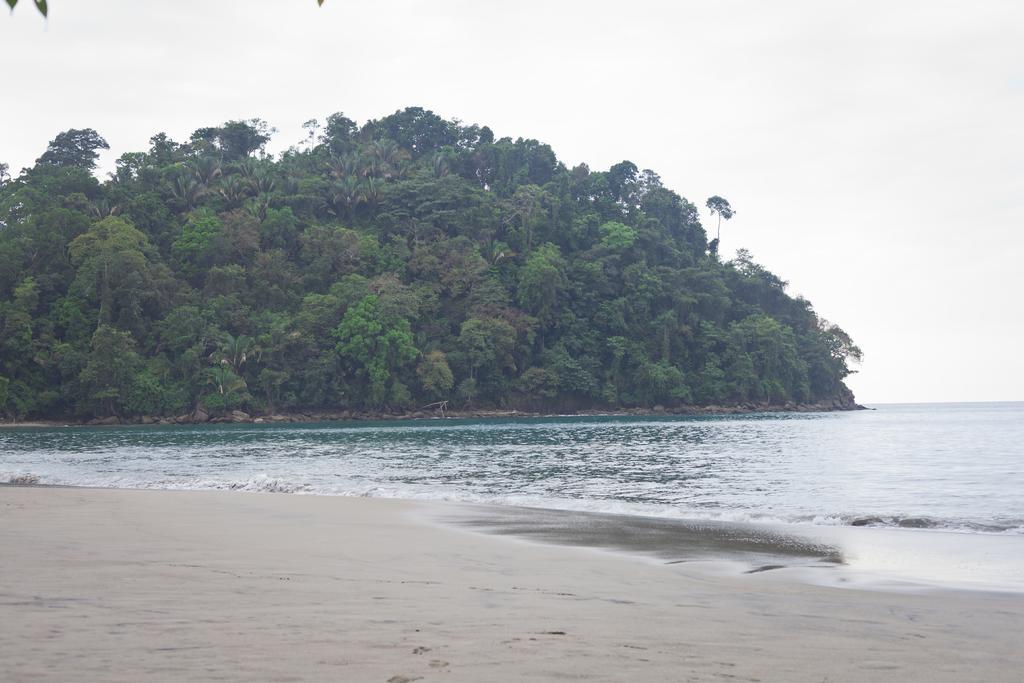Could you give a brief overview of what you see in this image? There is water and there are trees at the back. 